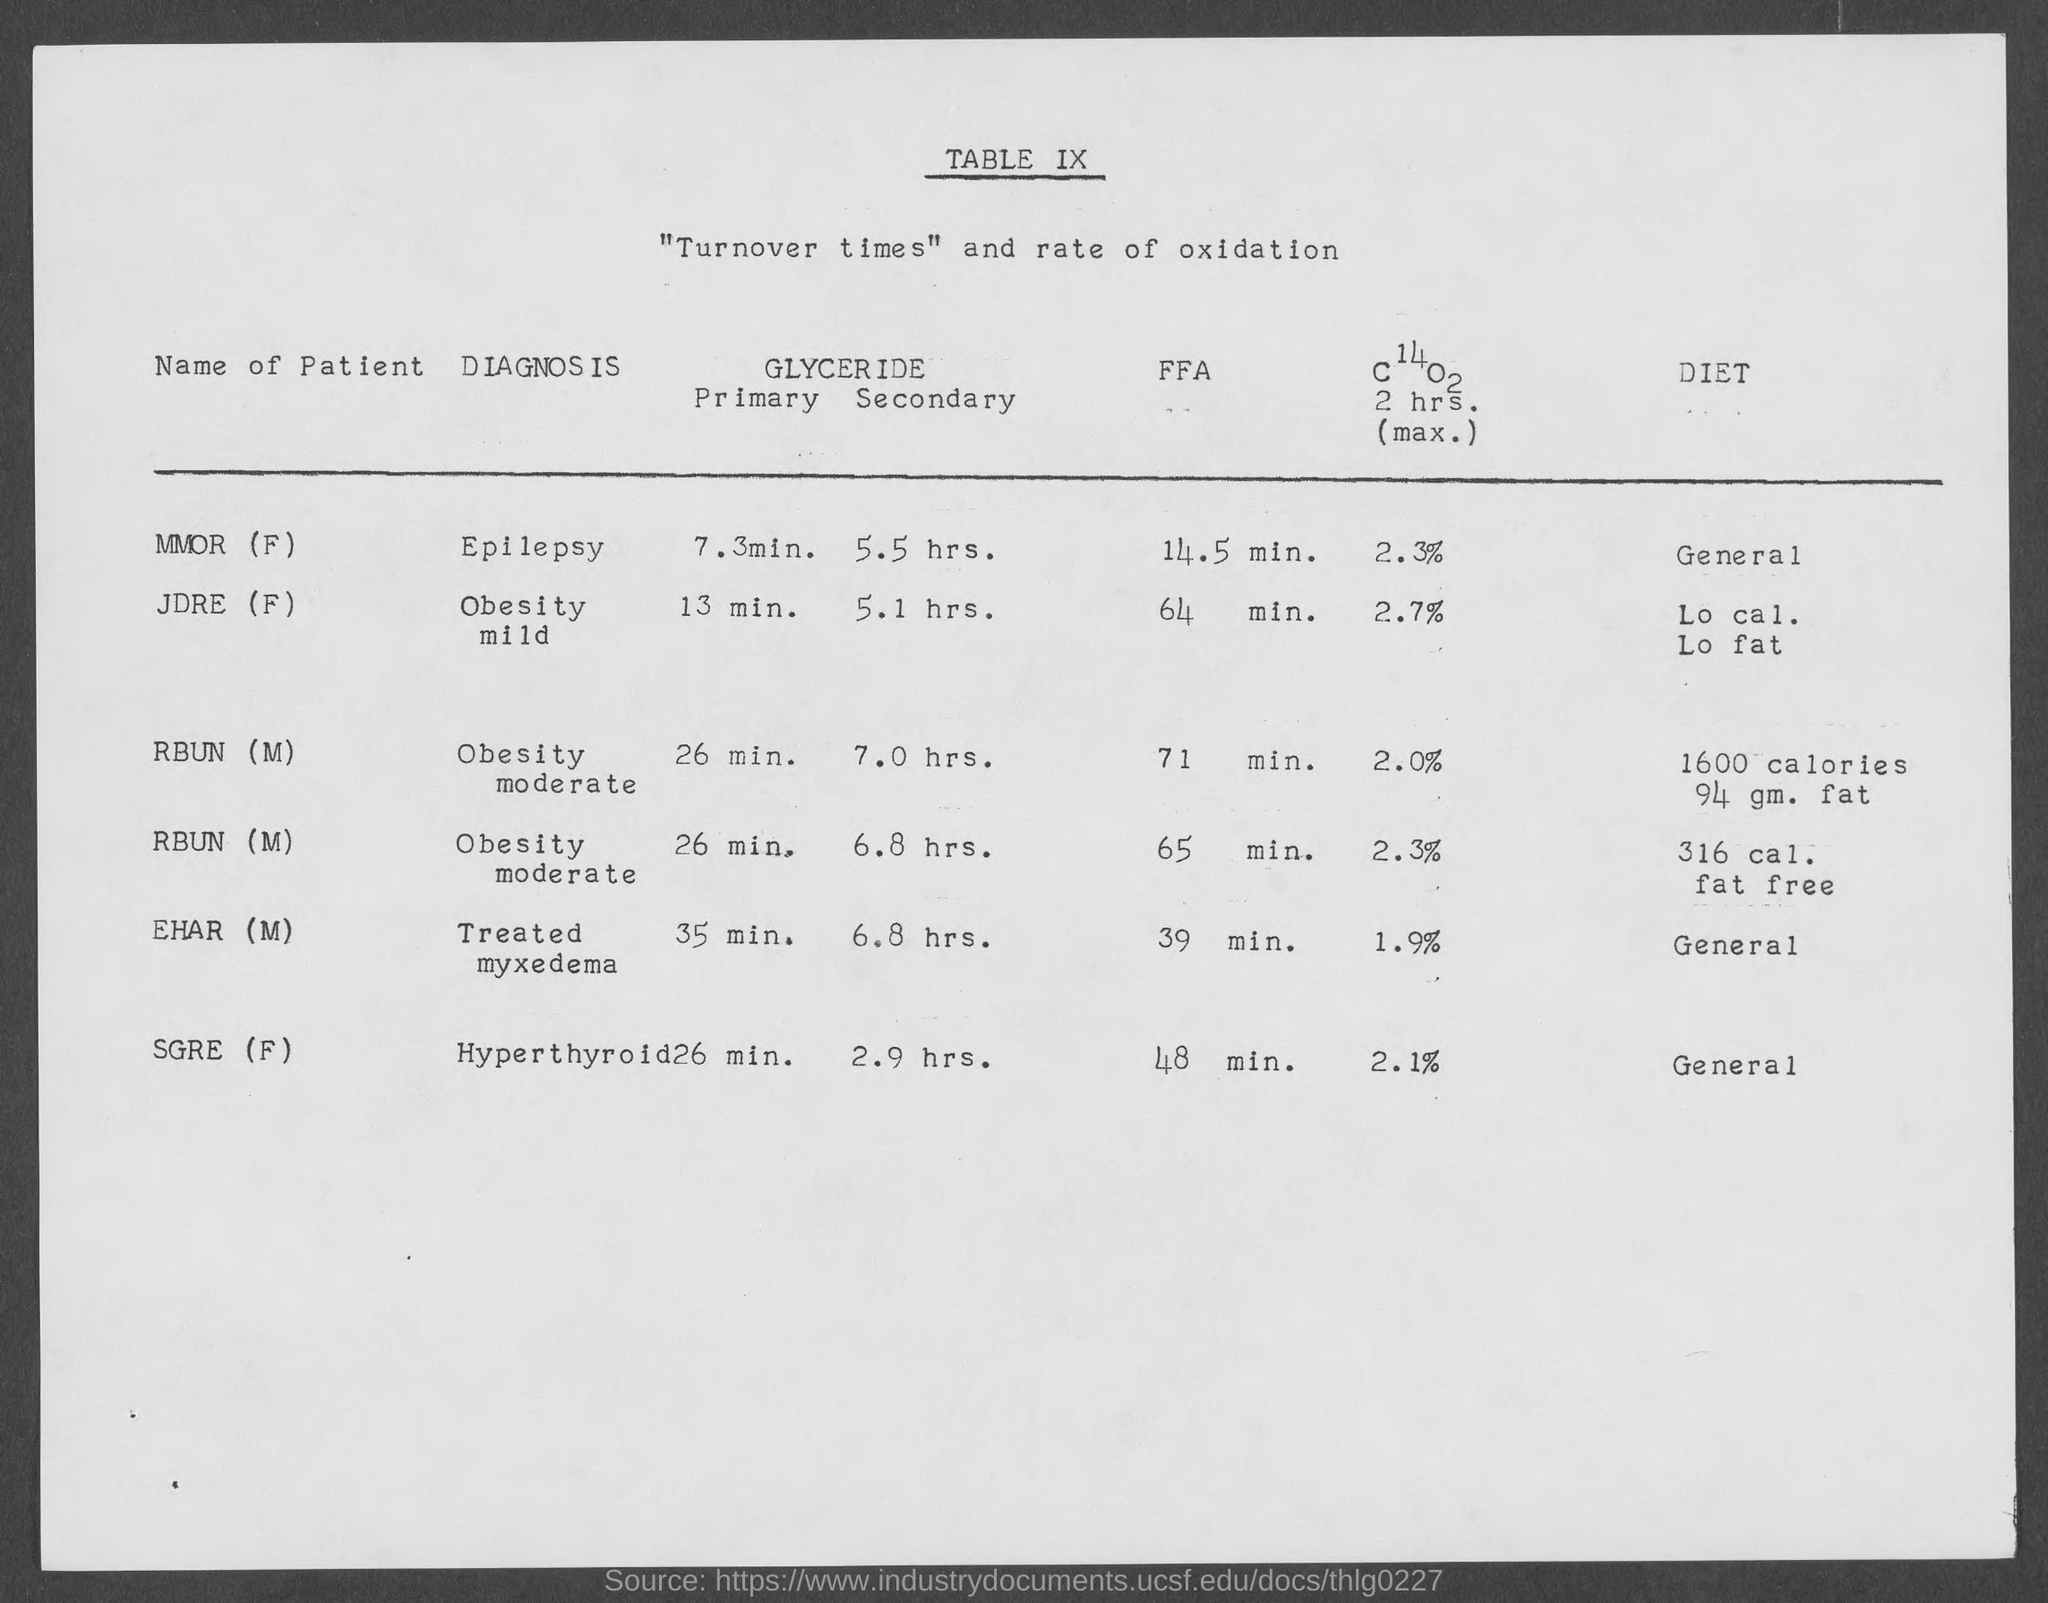Outline some significant characteristics in this image. The estimated time for the FFA for MMOR(F) is 14.5 minutes. What is the diet for MMOR (F) in general? A general diet for EHAR (M) is... The diagnosis for EHAR (M) is myxedema, and it was treated with myxedema. What is the table number? The table is located in IX.. 